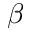Convert formula to latex. <formula><loc_0><loc_0><loc_500><loc_500>\beta</formula> 